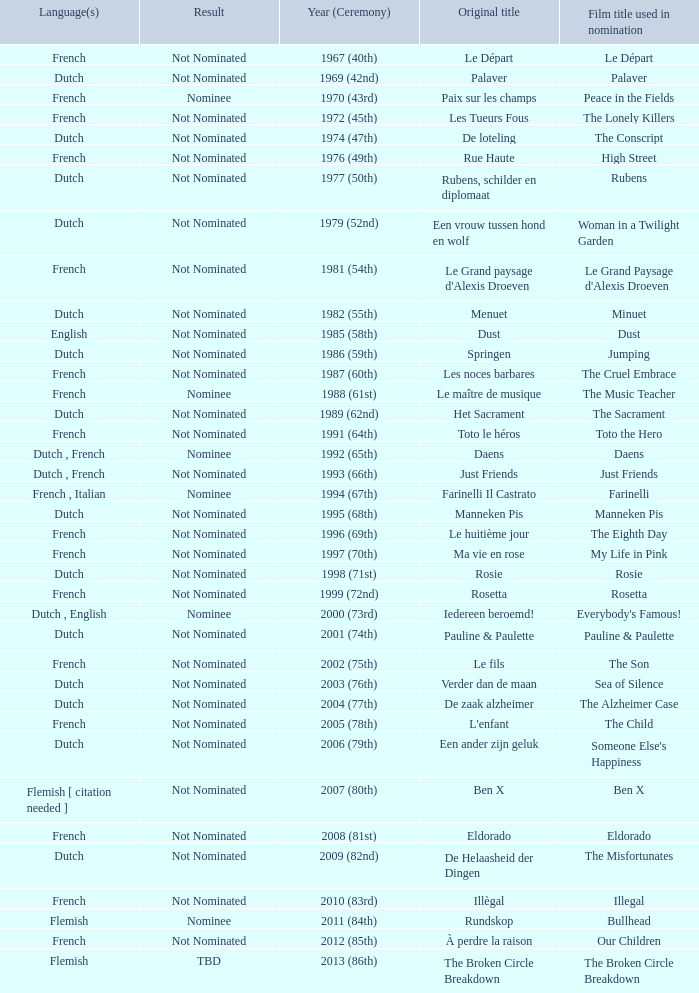What is the language of the film Rosie? Dutch. 